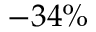<formula> <loc_0><loc_0><loc_500><loc_500>- 3 4 \%</formula> 